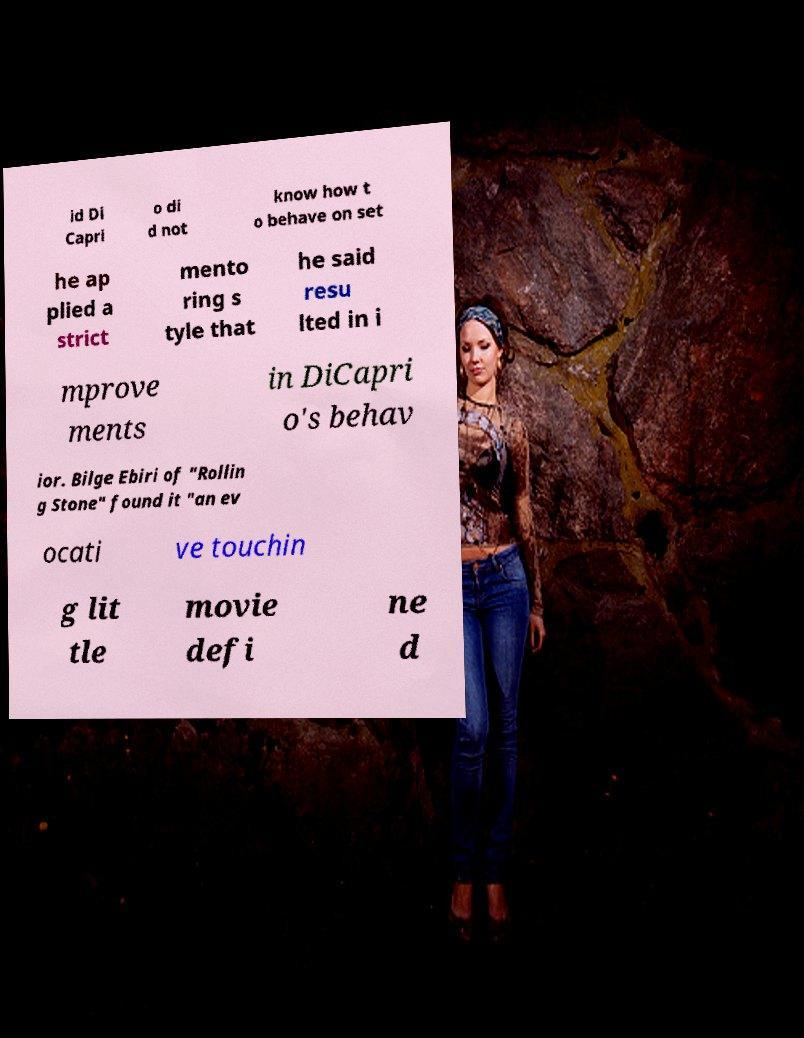Please read and relay the text visible in this image. What does it say? id Di Capri o di d not know how t o behave on set he ap plied a strict mento ring s tyle that he said resu lted in i mprove ments in DiCapri o's behav ior. Bilge Ebiri of "Rollin g Stone" found it "an ev ocati ve touchin g lit tle movie defi ne d 